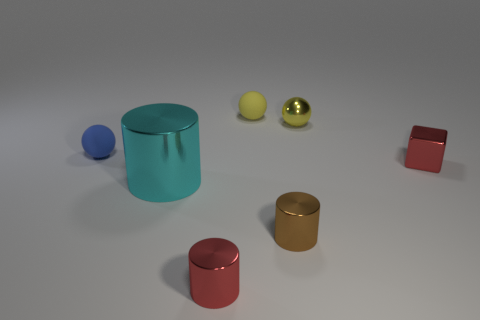Subtract all brown cylinders. How many yellow spheres are left? 2 Subtract all matte balls. How many balls are left? 1 Add 2 yellow rubber cylinders. How many objects exist? 9 Subtract 1 cylinders. How many cylinders are left? 2 Subtract all large metallic things. Subtract all balls. How many objects are left? 3 Add 7 metal cubes. How many metal cubes are left? 8 Add 2 tiny purple spheres. How many tiny purple spheres exist? 2 Subtract 0 green cylinders. How many objects are left? 7 Subtract all spheres. How many objects are left? 4 Subtract all cyan spheres. Subtract all red cubes. How many spheres are left? 3 